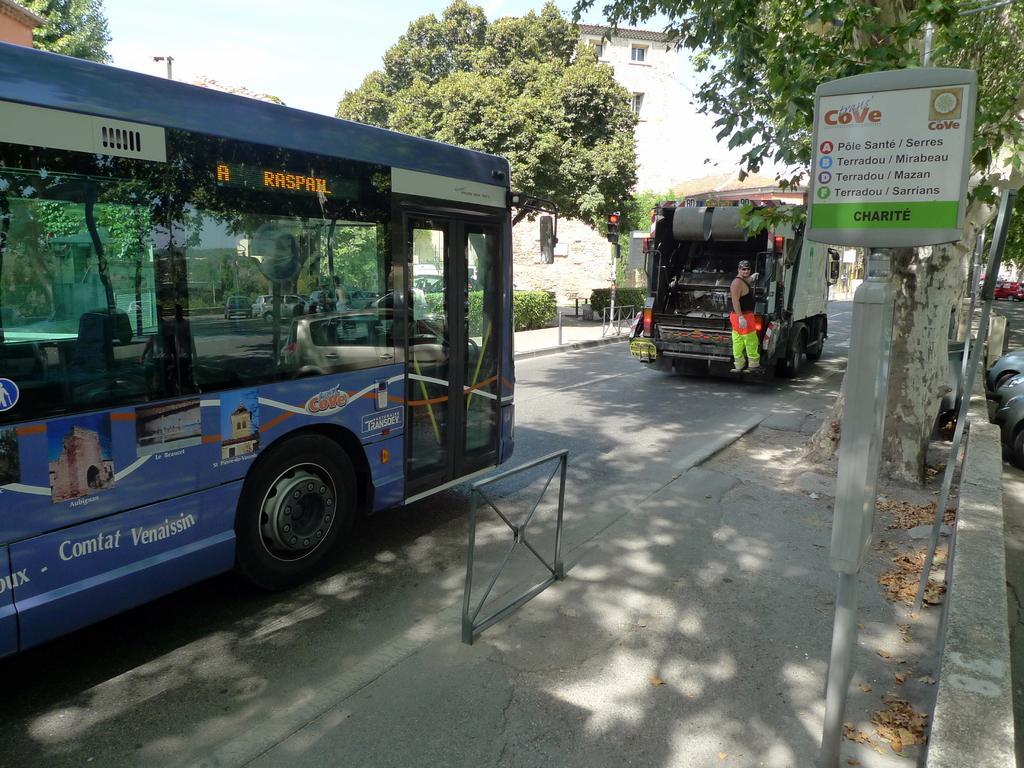In one or two sentences, can you explain what this image depicts? This picture is clicked outside the city. In this picture, we see the vehicles moving on the road. The man in the black T-shirt is standing beside the vehicle. In the middle of the picture, we see an iron stand. On the right side, we see a pole and a board in white and green color with some text written on it. Behind that, there are trees and beside that, we see cars parked on the road. There are trees, poles and buildings in the background. We even see the cars. At the top, we see the sky. 